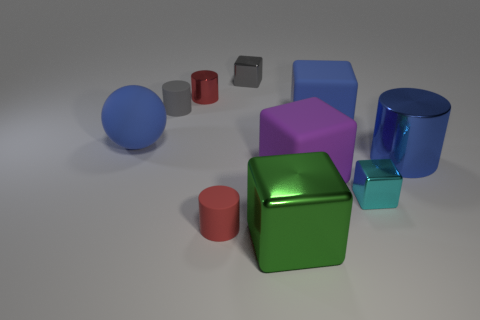Subtract 1 cubes. How many cubes are left? 4 Subtract all red blocks. Subtract all blue cylinders. How many blocks are left? 5 Subtract all cylinders. How many objects are left? 6 Add 8 gray metallic things. How many gray metallic things exist? 9 Subtract 1 cyan cubes. How many objects are left? 9 Subtract all big gray cylinders. Subtract all blue things. How many objects are left? 7 Add 2 big purple rubber things. How many big purple rubber things are left? 3 